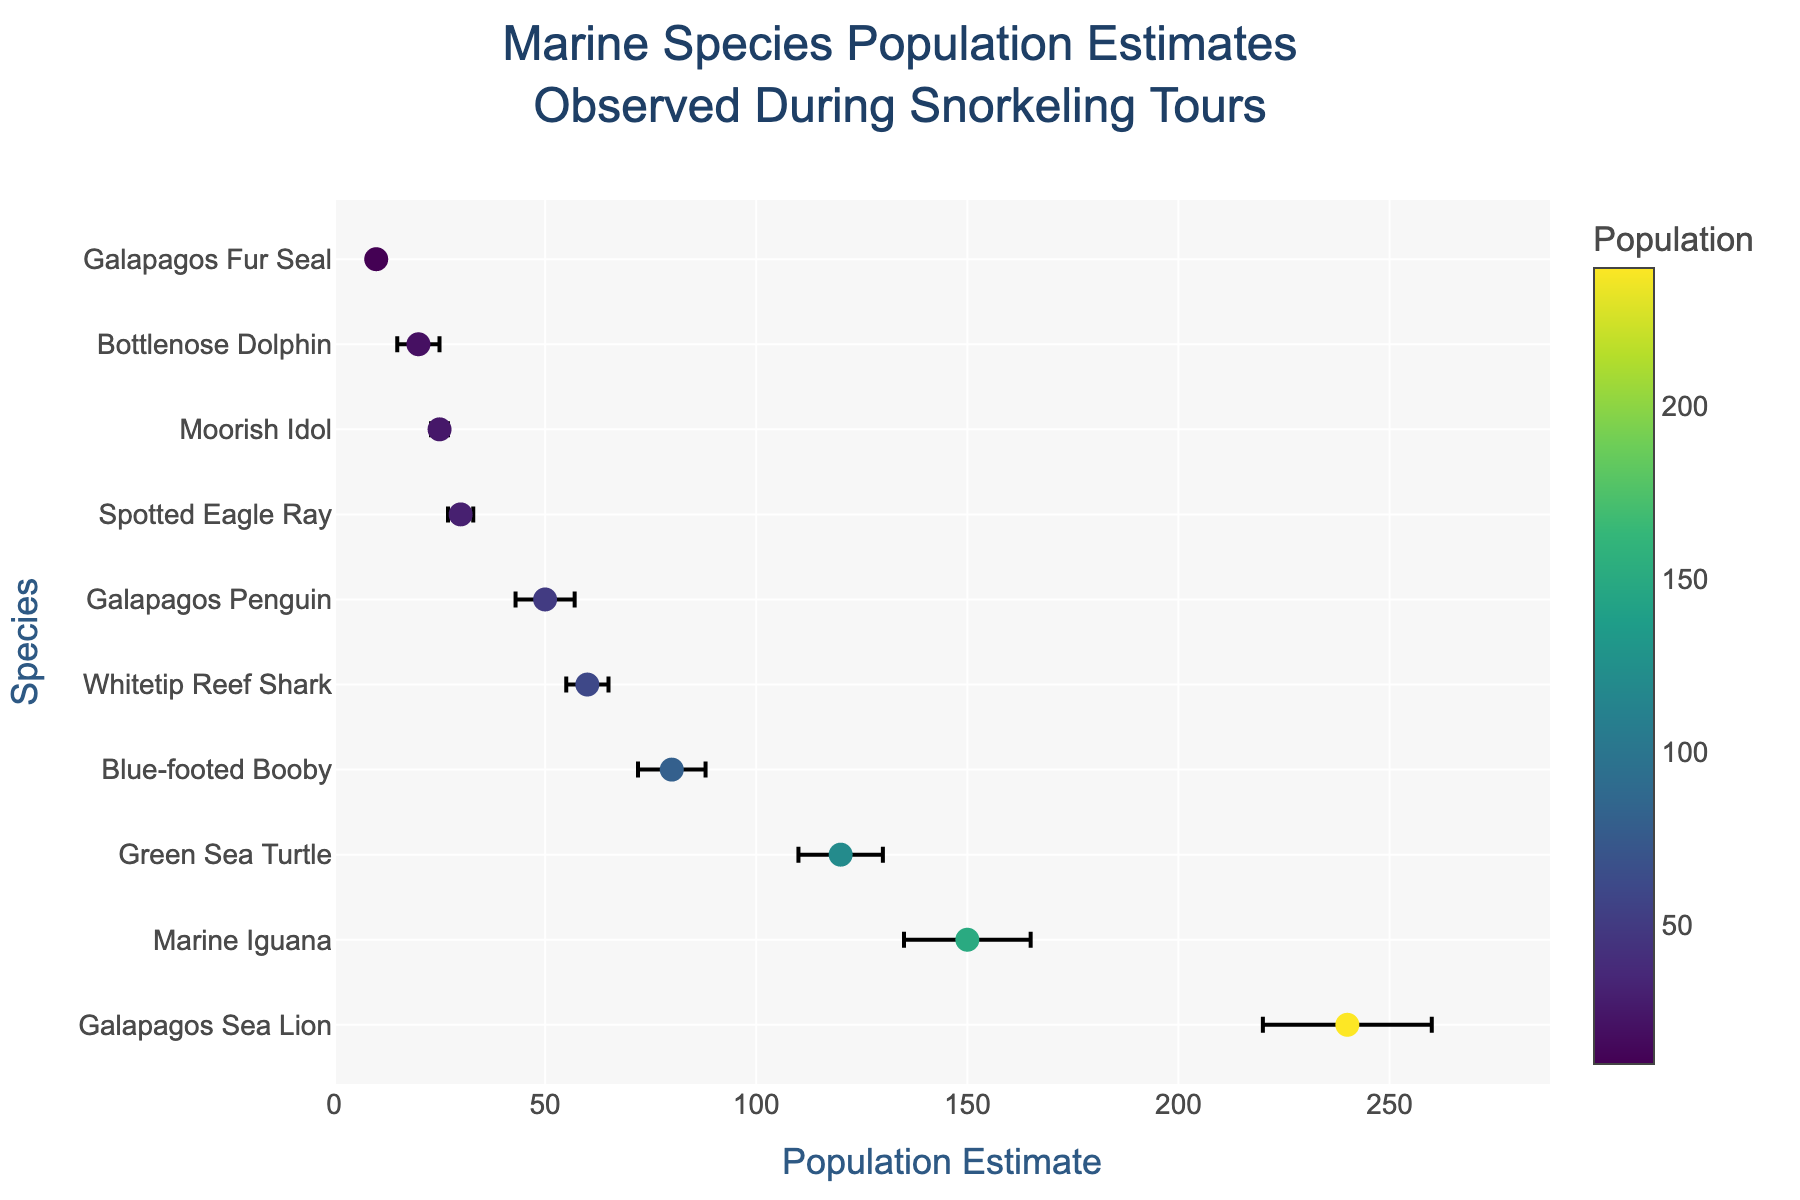How many marine species are observed during snorkeling tours? Observe the number of unique species names listed on the y-axis. There are 10 different species names.
Answer: 10 Which species has the highest population estimate? Look at the x-axis values and identify the species with the largest population estimate. The Galapagos Sea Lion has the highest population estimate of 240.
Answer: Galapagos Sea Lion What is the margin of error for the Blue-footed Booby's population estimate? Hover over the marker for the Blue-footed Booby or look at the error bars associated with it. The margin of error is denoted as a plus/minus value, which is 8.
Answer: 8 What is the total population estimate for the Marine Iguana and Green Sea Turtle combined? Add the population estimates for both species: Marine Iguana (150) and Green Sea Turtle (120). 150 + 120 = 270.
Answer: 270 Which species has the smallest margin of error? Identify the smallest error bars on the x-axis or check the hover information for each species. The Galapagos Fur Seal has the smallest margin of error of 1.
Answer: Galapagos Fur Seal How does the population estimate of the Whitetip Reef Shark compare to the Galapagos Penguin? Compare the population estimate values: Whitetip Reef Shark (60) and Galapagos Penguin (50). The Whitetip Reef Shark has a higher population estimate than the Galapagos Penguin.
Answer: Whitetip Reef Shark What is the average population estimate for species with more than 50 individuals? Identify and sum the population estimates for species with more than 50 individuals: Galapagos Sea Lion (240), Marine Iguana (150), Green Sea Turtle (120), Blue-footed Booby (80), and Whitetip Reef Shark (60). Sum: 240 + 150 + 120 + 80 + 60 = 650. There are 5 species. Average = 650 / 5 = 130.
Answer: 130 What is the difference in population estimates between the Spotted Eagle Ray and Moorish Idol? Subtract the population estimate of Moorish Idol (25) from that of Spotted Eagle Ray (30). 30 - 25 = 5.
Answer: 5 Which species has a population estimate closest to the average of all species? Calculate the average population estimate: (240 + 150 + 120 + 80 + 60 + 50 + 30 + 25 + 20 + 10) / 10 = 78.5. Identify the species with the closest estimate, which is the Blue-footed Booby with an estimate of 80.
Answer: Blue-footed Booby What range of population estimates do the error bars cover for the Green Sea Turtle? Identify the population estimate (120) and margin of error (10) for the Green Sea Turtle. The range is from 120 - 10 to 120 + 10, which is 110 to 130.
Answer: 110 to 130 